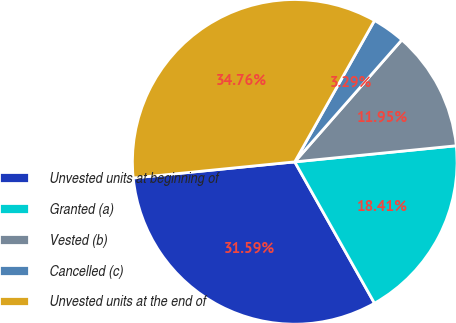Convert chart to OTSL. <chart><loc_0><loc_0><loc_500><loc_500><pie_chart><fcel>Unvested units at beginning of<fcel>Granted (a)<fcel>Vested (b)<fcel>Cancelled (c)<fcel>Unvested units at the end of<nl><fcel>31.59%<fcel>18.41%<fcel>11.95%<fcel>3.29%<fcel>34.76%<nl></chart> 